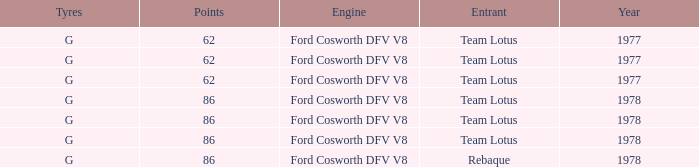What is the Focus that has a Year bigger than 1977? 86, 86, 86, 86. 